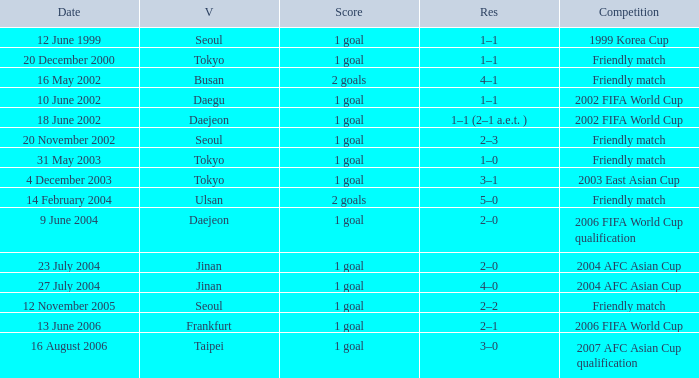What is the venue of the game on 20 November 2002? Seoul. 